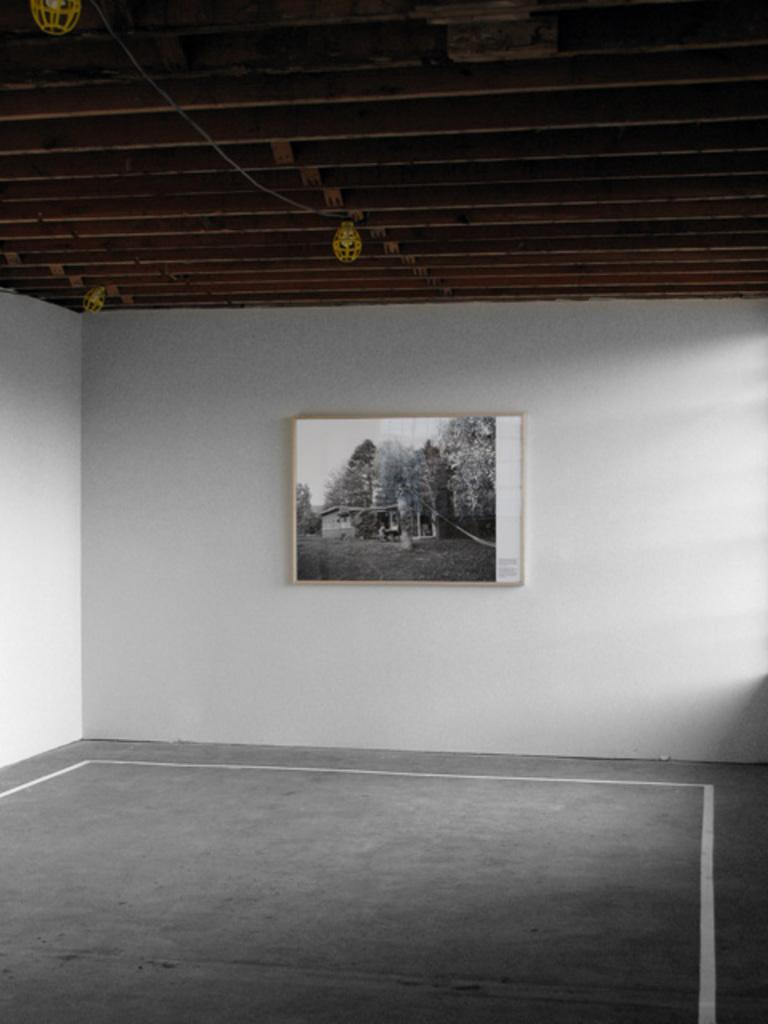What type of surface is visible at the bottom of the image? There is a floor in the image. What type of structure is visible at the top of the image? There is a roof in the image. What can be seen hanging on the wall in the image? There is a photo frame on the wall in the image. What else can be seen in the image besides the floor, roof, and photo frame? There are objects present in the image. What type of clam is used as a decoration in the image? There is no clam present in the image; it does not feature any seafood or marine life. 